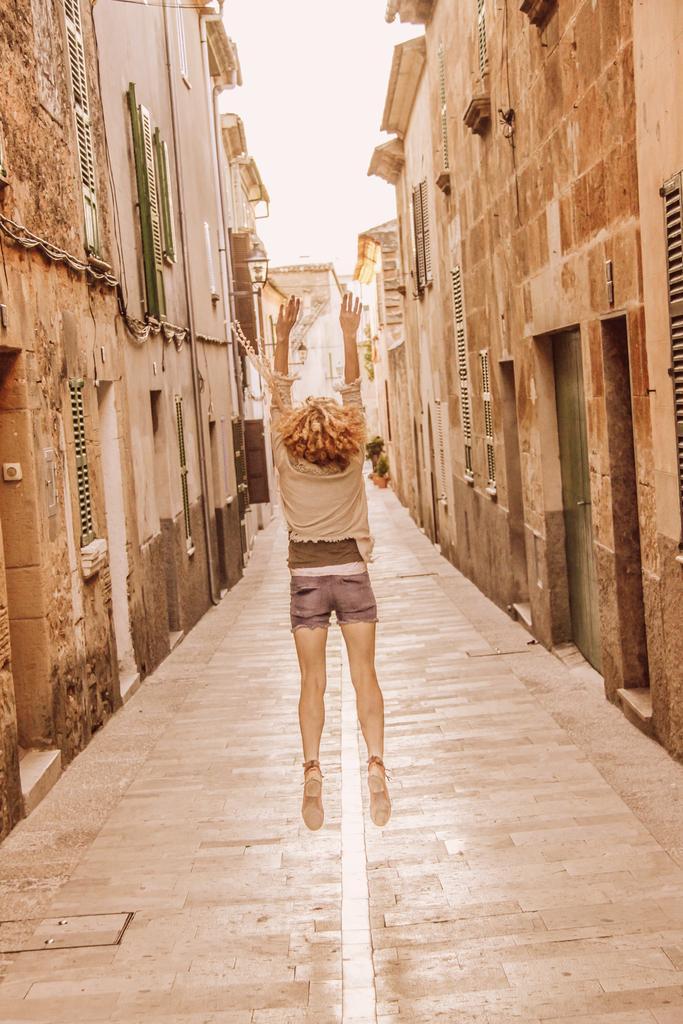Can you describe this image briefly? In this image on the right side and left side there are some houses and in the center there is one woman who is jumping, at the bottom there is a walkway. 